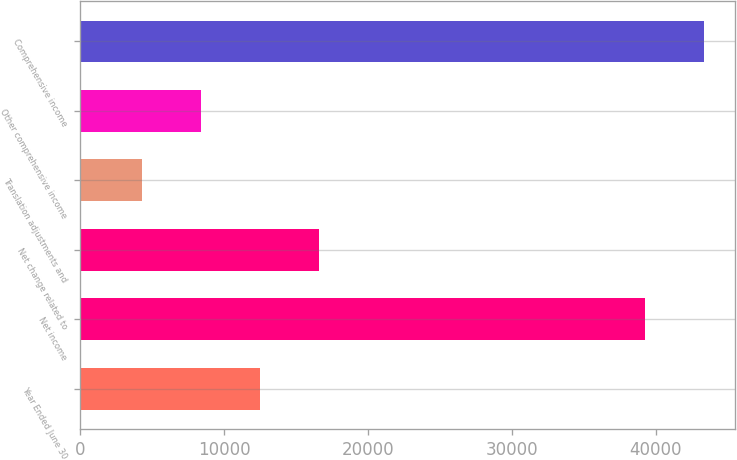Convert chart. <chart><loc_0><loc_0><loc_500><loc_500><bar_chart><fcel>Year Ended June 30<fcel>Net income<fcel>Net change related to<fcel>Translation adjustments and<fcel>Other comprehensive income<fcel>Comprehensive income<nl><fcel>12467.3<fcel>39240<fcel>16565.4<fcel>4271.1<fcel>8369.2<fcel>43338.1<nl></chart> 